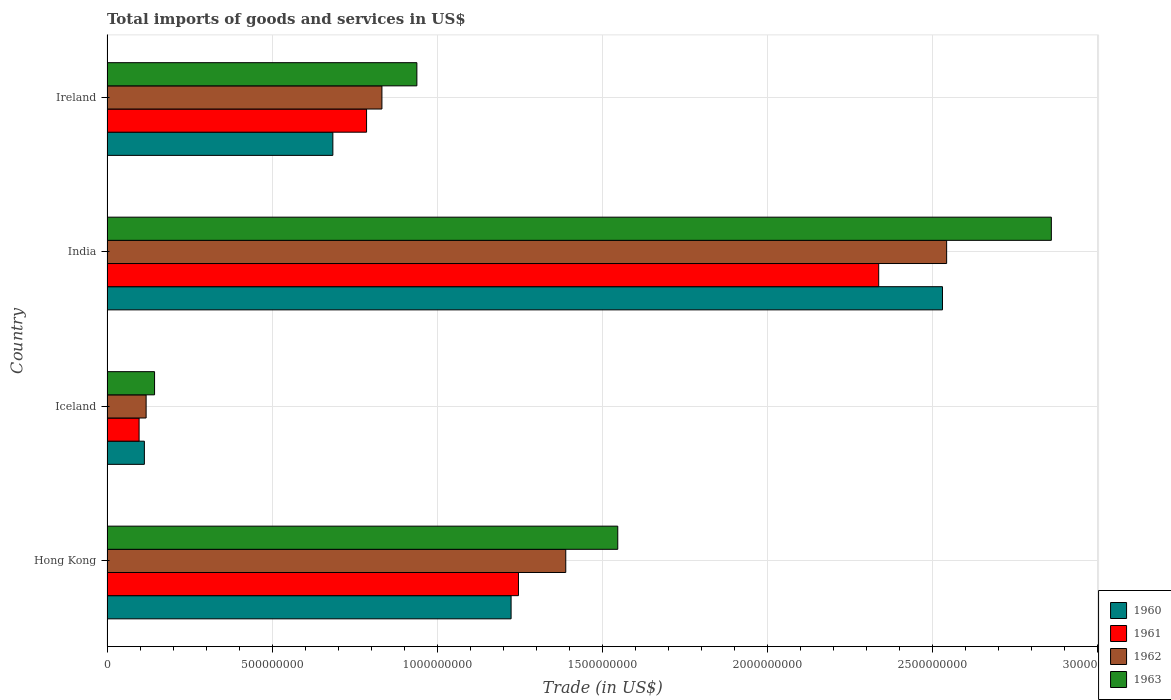How many different coloured bars are there?
Provide a short and direct response. 4. Are the number of bars per tick equal to the number of legend labels?
Your answer should be compact. Yes. Are the number of bars on each tick of the Y-axis equal?
Offer a very short reply. Yes. How many bars are there on the 4th tick from the top?
Offer a terse response. 4. What is the total imports of goods and services in 1963 in Hong Kong?
Offer a very short reply. 1.55e+09. Across all countries, what is the maximum total imports of goods and services in 1963?
Your response must be concise. 2.86e+09. Across all countries, what is the minimum total imports of goods and services in 1960?
Offer a terse response. 1.13e+08. In which country was the total imports of goods and services in 1963 maximum?
Give a very brief answer. India. In which country was the total imports of goods and services in 1961 minimum?
Your answer should be compact. Iceland. What is the total total imports of goods and services in 1962 in the graph?
Your answer should be compact. 4.88e+09. What is the difference between the total imports of goods and services in 1961 in Hong Kong and that in India?
Offer a very short reply. -1.09e+09. What is the difference between the total imports of goods and services in 1961 in Iceland and the total imports of goods and services in 1960 in Hong Kong?
Ensure brevity in your answer.  -1.13e+09. What is the average total imports of goods and services in 1961 per country?
Offer a very short reply. 1.12e+09. What is the difference between the total imports of goods and services in 1961 and total imports of goods and services in 1960 in Hong Kong?
Ensure brevity in your answer.  2.23e+07. What is the ratio of the total imports of goods and services in 1963 in Iceland to that in India?
Offer a terse response. 0.05. Is the total imports of goods and services in 1963 in Hong Kong less than that in Ireland?
Ensure brevity in your answer.  No. Is the difference between the total imports of goods and services in 1961 in Hong Kong and India greater than the difference between the total imports of goods and services in 1960 in Hong Kong and India?
Give a very brief answer. Yes. What is the difference between the highest and the second highest total imports of goods and services in 1962?
Give a very brief answer. 1.15e+09. What is the difference between the highest and the lowest total imports of goods and services in 1961?
Make the answer very short. 2.24e+09. In how many countries, is the total imports of goods and services in 1960 greater than the average total imports of goods and services in 1960 taken over all countries?
Your answer should be compact. 2. Is it the case that in every country, the sum of the total imports of goods and services in 1963 and total imports of goods and services in 1962 is greater than the sum of total imports of goods and services in 1960 and total imports of goods and services in 1961?
Ensure brevity in your answer.  No. How many bars are there?
Your response must be concise. 16. Are all the bars in the graph horizontal?
Your answer should be very brief. Yes. What is the difference between two consecutive major ticks on the X-axis?
Your answer should be very brief. 5.00e+08. Are the values on the major ticks of X-axis written in scientific E-notation?
Provide a succinct answer. No. What is the title of the graph?
Keep it short and to the point. Total imports of goods and services in US$. What is the label or title of the X-axis?
Your response must be concise. Trade (in US$). What is the label or title of the Y-axis?
Provide a short and direct response. Country. What is the Trade (in US$) in 1960 in Hong Kong?
Give a very brief answer. 1.22e+09. What is the Trade (in US$) in 1961 in Hong Kong?
Offer a terse response. 1.25e+09. What is the Trade (in US$) of 1962 in Hong Kong?
Provide a short and direct response. 1.39e+09. What is the Trade (in US$) of 1963 in Hong Kong?
Make the answer very short. 1.55e+09. What is the Trade (in US$) in 1960 in Iceland?
Keep it short and to the point. 1.13e+08. What is the Trade (in US$) in 1961 in Iceland?
Provide a short and direct response. 9.72e+07. What is the Trade (in US$) of 1962 in Iceland?
Your response must be concise. 1.18e+08. What is the Trade (in US$) of 1963 in Iceland?
Make the answer very short. 1.44e+08. What is the Trade (in US$) in 1960 in India?
Ensure brevity in your answer.  2.53e+09. What is the Trade (in US$) in 1961 in India?
Keep it short and to the point. 2.34e+09. What is the Trade (in US$) in 1962 in India?
Give a very brief answer. 2.54e+09. What is the Trade (in US$) in 1963 in India?
Your response must be concise. 2.86e+09. What is the Trade (in US$) in 1960 in Ireland?
Your answer should be very brief. 6.84e+08. What is the Trade (in US$) of 1961 in Ireland?
Give a very brief answer. 7.86e+08. What is the Trade (in US$) of 1962 in Ireland?
Make the answer very short. 8.33e+08. What is the Trade (in US$) of 1963 in Ireland?
Your answer should be compact. 9.39e+08. Across all countries, what is the maximum Trade (in US$) in 1960?
Provide a succinct answer. 2.53e+09. Across all countries, what is the maximum Trade (in US$) of 1961?
Your answer should be compact. 2.34e+09. Across all countries, what is the maximum Trade (in US$) in 1962?
Ensure brevity in your answer.  2.54e+09. Across all countries, what is the maximum Trade (in US$) of 1963?
Ensure brevity in your answer.  2.86e+09. Across all countries, what is the minimum Trade (in US$) of 1960?
Offer a very short reply. 1.13e+08. Across all countries, what is the minimum Trade (in US$) of 1961?
Give a very brief answer. 9.72e+07. Across all countries, what is the minimum Trade (in US$) in 1962?
Your answer should be very brief. 1.18e+08. Across all countries, what is the minimum Trade (in US$) in 1963?
Provide a short and direct response. 1.44e+08. What is the total Trade (in US$) of 1960 in the graph?
Keep it short and to the point. 4.55e+09. What is the total Trade (in US$) of 1961 in the graph?
Offer a very short reply. 4.47e+09. What is the total Trade (in US$) of 1962 in the graph?
Your response must be concise. 4.88e+09. What is the total Trade (in US$) of 1963 in the graph?
Ensure brevity in your answer.  5.49e+09. What is the difference between the Trade (in US$) in 1960 in Hong Kong and that in Iceland?
Offer a terse response. 1.11e+09. What is the difference between the Trade (in US$) in 1961 in Hong Kong and that in Iceland?
Provide a short and direct response. 1.15e+09. What is the difference between the Trade (in US$) of 1962 in Hong Kong and that in Iceland?
Keep it short and to the point. 1.27e+09. What is the difference between the Trade (in US$) in 1963 in Hong Kong and that in Iceland?
Make the answer very short. 1.40e+09. What is the difference between the Trade (in US$) in 1960 in Hong Kong and that in India?
Provide a short and direct response. -1.31e+09. What is the difference between the Trade (in US$) of 1961 in Hong Kong and that in India?
Provide a short and direct response. -1.09e+09. What is the difference between the Trade (in US$) in 1962 in Hong Kong and that in India?
Offer a very short reply. -1.15e+09. What is the difference between the Trade (in US$) in 1963 in Hong Kong and that in India?
Give a very brief answer. -1.31e+09. What is the difference between the Trade (in US$) of 1960 in Hong Kong and that in Ireland?
Your answer should be very brief. 5.40e+08. What is the difference between the Trade (in US$) of 1961 in Hong Kong and that in Ireland?
Make the answer very short. 4.60e+08. What is the difference between the Trade (in US$) of 1962 in Hong Kong and that in Ireland?
Make the answer very short. 5.57e+08. What is the difference between the Trade (in US$) of 1963 in Hong Kong and that in Ireland?
Give a very brief answer. 6.08e+08. What is the difference between the Trade (in US$) of 1960 in Iceland and that in India?
Your answer should be very brief. -2.42e+09. What is the difference between the Trade (in US$) in 1961 in Iceland and that in India?
Offer a very short reply. -2.24e+09. What is the difference between the Trade (in US$) in 1962 in Iceland and that in India?
Make the answer very short. -2.42e+09. What is the difference between the Trade (in US$) in 1963 in Iceland and that in India?
Provide a succinct answer. -2.72e+09. What is the difference between the Trade (in US$) in 1960 in Iceland and that in Ireland?
Keep it short and to the point. -5.71e+08. What is the difference between the Trade (in US$) of 1961 in Iceland and that in Ireland?
Ensure brevity in your answer.  -6.89e+08. What is the difference between the Trade (in US$) of 1962 in Iceland and that in Ireland?
Your answer should be very brief. -7.14e+08. What is the difference between the Trade (in US$) of 1963 in Iceland and that in Ireland?
Keep it short and to the point. -7.95e+08. What is the difference between the Trade (in US$) in 1960 in India and that in Ireland?
Ensure brevity in your answer.  1.85e+09. What is the difference between the Trade (in US$) in 1961 in India and that in Ireland?
Offer a very short reply. 1.55e+09. What is the difference between the Trade (in US$) of 1962 in India and that in Ireland?
Provide a succinct answer. 1.71e+09. What is the difference between the Trade (in US$) of 1963 in India and that in Ireland?
Provide a short and direct response. 1.92e+09. What is the difference between the Trade (in US$) of 1960 in Hong Kong and the Trade (in US$) of 1961 in Iceland?
Make the answer very short. 1.13e+09. What is the difference between the Trade (in US$) in 1960 in Hong Kong and the Trade (in US$) in 1962 in Iceland?
Provide a succinct answer. 1.11e+09. What is the difference between the Trade (in US$) of 1960 in Hong Kong and the Trade (in US$) of 1963 in Iceland?
Your answer should be compact. 1.08e+09. What is the difference between the Trade (in US$) of 1961 in Hong Kong and the Trade (in US$) of 1962 in Iceland?
Your answer should be very brief. 1.13e+09. What is the difference between the Trade (in US$) of 1961 in Hong Kong and the Trade (in US$) of 1963 in Iceland?
Make the answer very short. 1.10e+09. What is the difference between the Trade (in US$) of 1962 in Hong Kong and the Trade (in US$) of 1963 in Iceland?
Keep it short and to the point. 1.25e+09. What is the difference between the Trade (in US$) of 1960 in Hong Kong and the Trade (in US$) of 1961 in India?
Provide a short and direct response. -1.11e+09. What is the difference between the Trade (in US$) of 1960 in Hong Kong and the Trade (in US$) of 1962 in India?
Your answer should be compact. -1.32e+09. What is the difference between the Trade (in US$) in 1960 in Hong Kong and the Trade (in US$) in 1963 in India?
Keep it short and to the point. -1.64e+09. What is the difference between the Trade (in US$) of 1961 in Hong Kong and the Trade (in US$) of 1962 in India?
Offer a very short reply. -1.30e+09. What is the difference between the Trade (in US$) of 1961 in Hong Kong and the Trade (in US$) of 1963 in India?
Give a very brief answer. -1.61e+09. What is the difference between the Trade (in US$) in 1962 in Hong Kong and the Trade (in US$) in 1963 in India?
Provide a short and direct response. -1.47e+09. What is the difference between the Trade (in US$) in 1960 in Hong Kong and the Trade (in US$) in 1961 in Ireland?
Your answer should be very brief. 4.38e+08. What is the difference between the Trade (in US$) of 1960 in Hong Kong and the Trade (in US$) of 1962 in Ireland?
Make the answer very short. 3.91e+08. What is the difference between the Trade (in US$) in 1960 in Hong Kong and the Trade (in US$) in 1963 in Ireland?
Provide a succinct answer. 2.85e+08. What is the difference between the Trade (in US$) in 1961 in Hong Kong and the Trade (in US$) in 1962 in Ireland?
Give a very brief answer. 4.14e+08. What is the difference between the Trade (in US$) in 1961 in Hong Kong and the Trade (in US$) in 1963 in Ireland?
Keep it short and to the point. 3.08e+08. What is the difference between the Trade (in US$) of 1962 in Hong Kong and the Trade (in US$) of 1963 in Ireland?
Offer a terse response. 4.51e+08. What is the difference between the Trade (in US$) of 1960 in Iceland and the Trade (in US$) of 1961 in India?
Provide a short and direct response. -2.22e+09. What is the difference between the Trade (in US$) in 1960 in Iceland and the Trade (in US$) in 1962 in India?
Give a very brief answer. -2.43e+09. What is the difference between the Trade (in US$) of 1960 in Iceland and the Trade (in US$) of 1963 in India?
Provide a succinct answer. -2.75e+09. What is the difference between the Trade (in US$) in 1961 in Iceland and the Trade (in US$) in 1962 in India?
Provide a succinct answer. -2.45e+09. What is the difference between the Trade (in US$) in 1961 in Iceland and the Trade (in US$) in 1963 in India?
Offer a very short reply. -2.76e+09. What is the difference between the Trade (in US$) of 1962 in Iceland and the Trade (in US$) of 1963 in India?
Provide a succinct answer. -2.74e+09. What is the difference between the Trade (in US$) of 1960 in Iceland and the Trade (in US$) of 1961 in Ireland?
Make the answer very short. -6.73e+08. What is the difference between the Trade (in US$) of 1960 in Iceland and the Trade (in US$) of 1962 in Ireland?
Provide a short and direct response. -7.20e+08. What is the difference between the Trade (in US$) in 1960 in Iceland and the Trade (in US$) in 1963 in Ireland?
Offer a very short reply. -8.25e+08. What is the difference between the Trade (in US$) of 1961 in Iceland and the Trade (in US$) of 1962 in Ireland?
Give a very brief answer. -7.35e+08. What is the difference between the Trade (in US$) in 1961 in Iceland and the Trade (in US$) in 1963 in Ireland?
Keep it short and to the point. -8.41e+08. What is the difference between the Trade (in US$) of 1962 in Iceland and the Trade (in US$) of 1963 in Ireland?
Ensure brevity in your answer.  -8.20e+08. What is the difference between the Trade (in US$) in 1960 in India and the Trade (in US$) in 1961 in Ireland?
Keep it short and to the point. 1.74e+09. What is the difference between the Trade (in US$) in 1960 in India and the Trade (in US$) in 1962 in Ireland?
Your answer should be compact. 1.70e+09. What is the difference between the Trade (in US$) in 1960 in India and the Trade (in US$) in 1963 in Ireland?
Your answer should be very brief. 1.59e+09. What is the difference between the Trade (in US$) of 1961 in India and the Trade (in US$) of 1962 in Ireland?
Provide a short and direct response. 1.50e+09. What is the difference between the Trade (in US$) in 1961 in India and the Trade (in US$) in 1963 in Ireland?
Your answer should be compact. 1.40e+09. What is the difference between the Trade (in US$) in 1962 in India and the Trade (in US$) in 1963 in Ireland?
Provide a succinct answer. 1.60e+09. What is the average Trade (in US$) of 1960 per country?
Offer a very short reply. 1.14e+09. What is the average Trade (in US$) of 1961 per country?
Offer a terse response. 1.12e+09. What is the average Trade (in US$) of 1962 per country?
Your answer should be very brief. 1.22e+09. What is the average Trade (in US$) of 1963 per country?
Keep it short and to the point. 1.37e+09. What is the difference between the Trade (in US$) of 1960 and Trade (in US$) of 1961 in Hong Kong?
Provide a short and direct response. -2.23e+07. What is the difference between the Trade (in US$) in 1960 and Trade (in US$) in 1962 in Hong Kong?
Offer a very short reply. -1.66e+08. What is the difference between the Trade (in US$) in 1960 and Trade (in US$) in 1963 in Hong Kong?
Your response must be concise. -3.23e+08. What is the difference between the Trade (in US$) in 1961 and Trade (in US$) in 1962 in Hong Kong?
Give a very brief answer. -1.43e+08. What is the difference between the Trade (in US$) in 1961 and Trade (in US$) in 1963 in Hong Kong?
Make the answer very short. -3.01e+08. What is the difference between the Trade (in US$) in 1962 and Trade (in US$) in 1963 in Hong Kong?
Make the answer very short. -1.57e+08. What is the difference between the Trade (in US$) in 1960 and Trade (in US$) in 1961 in Iceland?
Offer a very short reply. 1.60e+07. What is the difference between the Trade (in US$) of 1960 and Trade (in US$) of 1962 in Iceland?
Keep it short and to the point. -5.31e+06. What is the difference between the Trade (in US$) of 1960 and Trade (in US$) of 1963 in Iceland?
Give a very brief answer. -3.09e+07. What is the difference between the Trade (in US$) of 1961 and Trade (in US$) of 1962 in Iceland?
Your answer should be compact. -2.13e+07. What is the difference between the Trade (in US$) of 1961 and Trade (in US$) of 1963 in Iceland?
Provide a succinct answer. -4.68e+07. What is the difference between the Trade (in US$) in 1962 and Trade (in US$) in 1963 in Iceland?
Provide a short and direct response. -2.56e+07. What is the difference between the Trade (in US$) in 1960 and Trade (in US$) in 1961 in India?
Offer a very short reply. 1.93e+08. What is the difference between the Trade (in US$) of 1960 and Trade (in US$) of 1962 in India?
Your answer should be very brief. -1.26e+07. What is the difference between the Trade (in US$) of 1960 and Trade (in US$) of 1963 in India?
Give a very brief answer. -3.30e+08. What is the difference between the Trade (in US$) in 1961 and Trade (in US$) in 1962 in India?
Provide a succinct answer. -2.06e+08. What is the difference between the Trade (in US$) of 1961 and Trade (in US$) of 1963 in India?
Make the answer very short. -5.23e+08. What is the difference between the Trade (in US$) in 1962 and Trade (in US$) in 1963 in India?
Keep it short and to the point. -3.17e+08. What is the difference between the Trade (in US$) of 1960 and Trade (in US$) of 1961 in Ireland?
Your answer should be compact. -1.02e+08. What is the difference between the Trade (in US$) in 1960 and Trade (in US$) in 1962 in Ireland?
Ensure brevity in your answer.  -1.49e+08. What is the difference between the Trade (in US$) of 1960 and Trade (in US$) of 1963 in Ireland?
Make the answer very short. -2.54e+08. What is the difference between the Trade (in US$) of 1961 and Trade (in US$) of 1962 in Ireland?
Your answer should be compact. -4.65e+07. What is the difference between the Trade (in US$) in 1961 and Trade (in US$) in 1963 in Ireland?
Make the answer very short. -1.52e+08. What is the difference between the Trade (in US$) of 1962 and Trade (in US$) of 1963 in Ireland?
Offer a terse response. -1.06e+08. What is the ratio of the Trade (in US$) of 1960 in Hong Kong to that in Iceland?
Provide a short and direct response. 10.81. What is the ratio of the Trade (in US$) of 1961 in Hong Kong to that in Iceland?
Provide a succinct answer. 12.82. What is the ratio of the Trade (in US$) of 1962 in Hong Kong to that in Iceland?
Provide a succinct answer. 11.73. What is the ratio of the Trade (in US$) in 1963 in Hong Kong to that in Iceland?
Provide a succinct answer. 10.74. What is the ratio of the Trade (in US$) in 1960 in Hong Kong to that in India?
Provide a short and direct response. 0.48. What is the ratio of the Trade (in US$) of 1961 in Hong Kong to that in India?
Offer a very short reply. 0.53. What is the ratio of the Trade (in US$) of 1962 in Hong Kong to that in India?
Provide a short and direct response. 0.55. What is the ratio of the Trade (in US$) of 1963 in Hong Kong to that in India?
Provide a succinct answer. 0.54. What is the ratio of the Trade (in US$) in 1960 in Hong Kong to that in Ireland?
Provide a short and direct response. 1.79. What is the ratio of the Trade (in US$) in 1961 in Hong Kong to that in Ireland?
Offer a very short reply. 1.59. What is the ratio of the Trade (in US$) of 1962 in Hong Kong to that in Ireland?
Your response must be concise. 1.67. What is the ratio of the Trade (in US$) of 1963 in Hong Kong to that in Ireland?
Ensure brevity in your answer.  1.65. What is the ratio of the Trade (in US$) of 1960 in Iceland to that in India?
Offer a terse response. 0.04. What is the ratio of the Trade (in US$) in 1961 in Iceland to that in India?
Make the answer very short. 0.04. What is the ratio of the Trade (in US$) of 1962 in Iceland to that in India?
Ensure brevity in your answer.  0.05. What is the ratio of the Trade (in US$) of 1963 in Iceland to that in India?
Offer a very short reply. 0.05. What is the ratio of the Trade (in US$) of 1960 in Iceland to that in Ireland?
Ensure brevity in your answer.  0.17. What is the ratio of the Trade (in US$) of 1961 in Iceland to that in Ireland?
Your response must be concise. 0.12. What is the ratio of the Trade (in US$) of 1962 in Iceland to that in Ireland?
Your answer should be very brief. 0.14. What is the ratio of the Trade (in US$) in 1963 in Iceland to that in Ireland?
Offer a terse response. 0.15. What is the ratio of the Trade (in US$) of 1960 in India to that in Ireland?
Ensure brevity in your answer.  3.7. What is the ratio of the Trade (in US$) in 1961 in India to that in Ireland?
Offer a very short reply. 2.97. What is the ratio of the Trade (in US$) in 1962 in India to that in Ireland?
Provide a short and direct response. 3.05. What is the ratio of the Trade (in US$) in 1963 in India to that in Ireland?
Offer a terse response. 3.05. What is the difference between the highest and the second highest Trade (in US$) of 1960?
Give a very brief answer. 1.31e+09. What is the difference between the highest and the second highest Trade (in US$) of 1961?
Make the answer very short. 1.09e+09. What is the difference between the highest and the second highest Trade (in US$) in 1962?
Ensure brevity in your answer.  1.15e+09. What is the difference between the highest and the second highest Trade (in US$) of 1963?
Offer a terse response. 1.31e+09. What is the difference between the highest and the lowest Trade (in US$) of 1960?
Your answer should be very brief. 2.42e+09. What is the difference between the highest and the lowest Trade (in US$) of 1961?
Your response must be concise. 2.24e+09. What is the difference between the highest and the lowest Trade (in US$) of 1962?
Offer a terse response. 2.42e+09. What is the difference between the highest and the lowest Trade (in US$) of 1963?
Provide a short and direct response. 2.72e+09. 